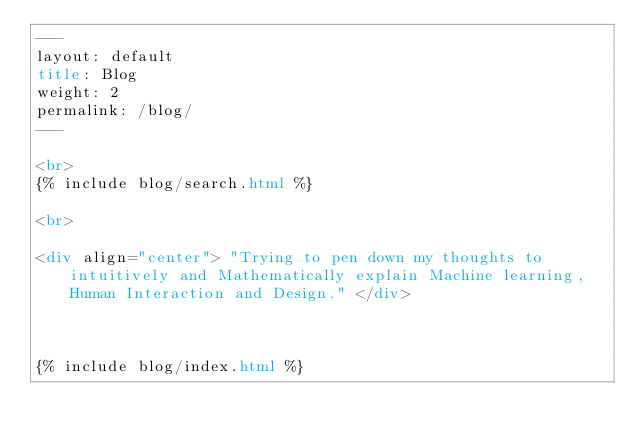<code> <loc_0><loc_0><loc_500><loc_500><_HTML_>---
layout: default
title: Blog
weight: 2
permalink: /blog/
---

<br>
{% include blog/search.html %}  

<br>

<div align="center"> "Trying to pen down my thoughts to intuitively and Mathematically explain Machine learning, Human Interaction and Design." </div>  



{% include blog/index.html %}</code> 